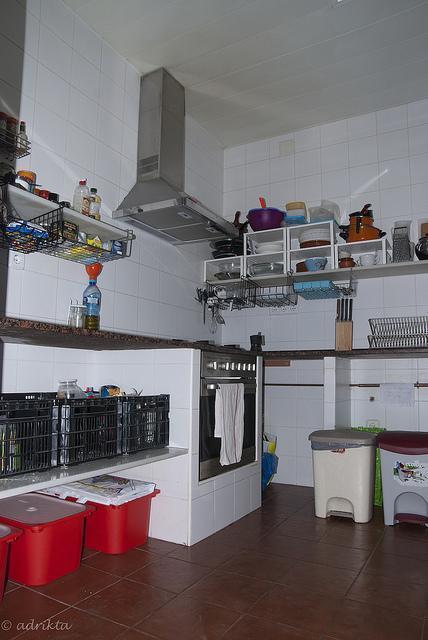How many ovens can be seen?
Give a very brief answer. 1. 